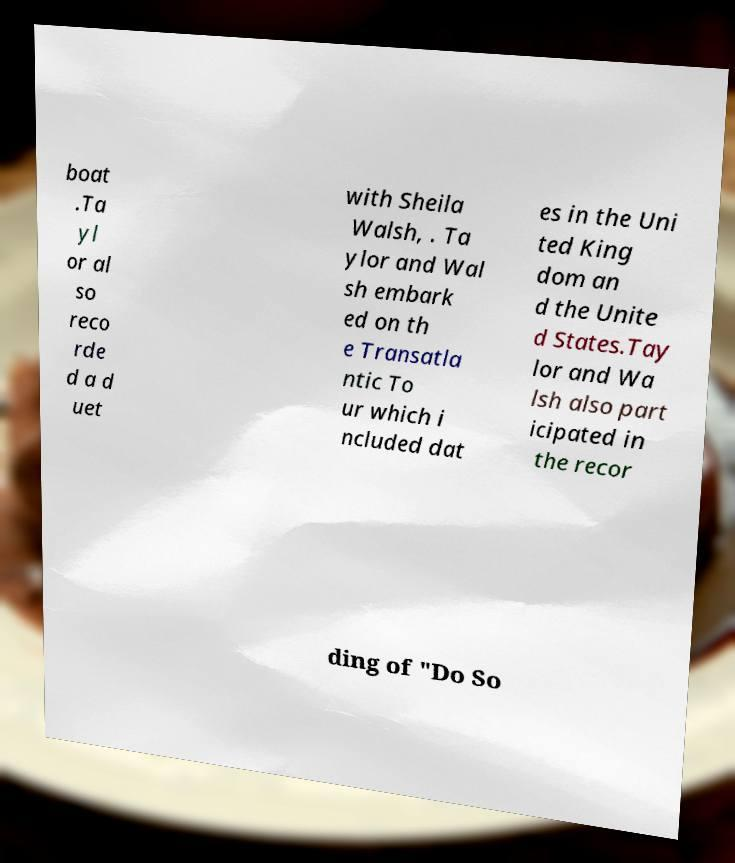Please identify and transcribe the text found in this image. boat .Ta yl or al so reco rde d a d uet with Sheila Walsh, . Ta ylor and Wal sh embark ed on th e Transatla ntic To ur which i ncluded dat es in the Uni ted King dom an d the Unite d States.Tay lor and Wa lsh also part icipated in the recor ding of "Do So 